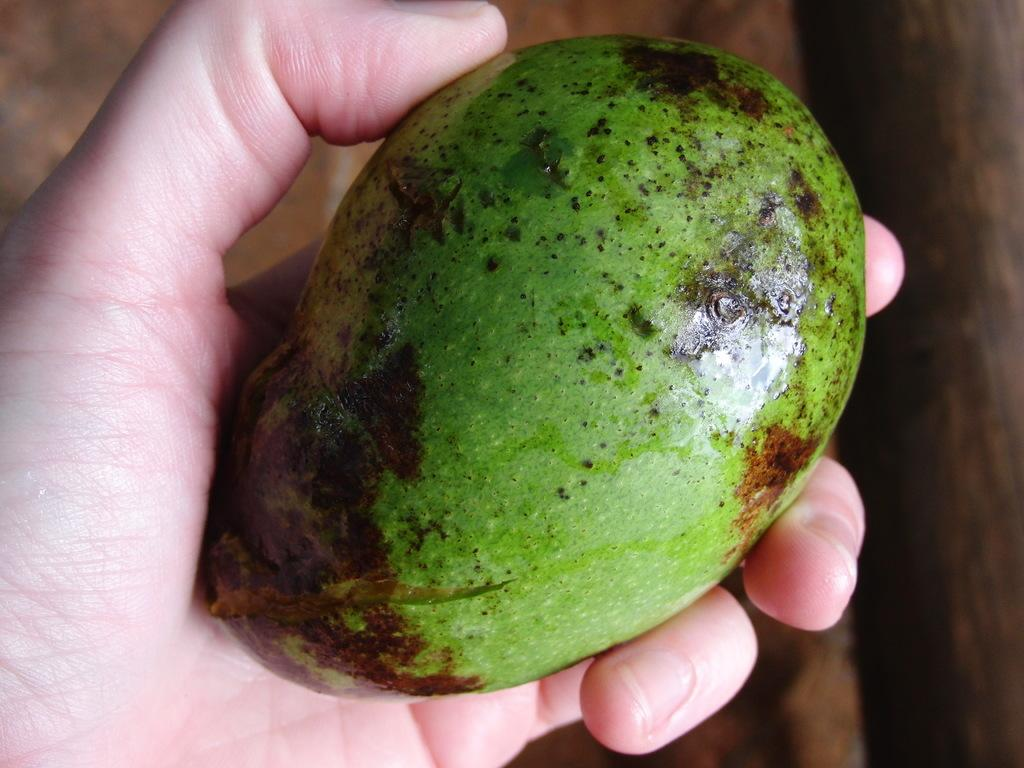What type of fruit is in the image? There is a raw mango in the image. How is the raw mango being held? A person is holding the raw mango in their hand. What does the tongue of the person holding the raw mango look like in the image? There is no visible tongue in the image, as the person is only holding the raw mango in their hand. 